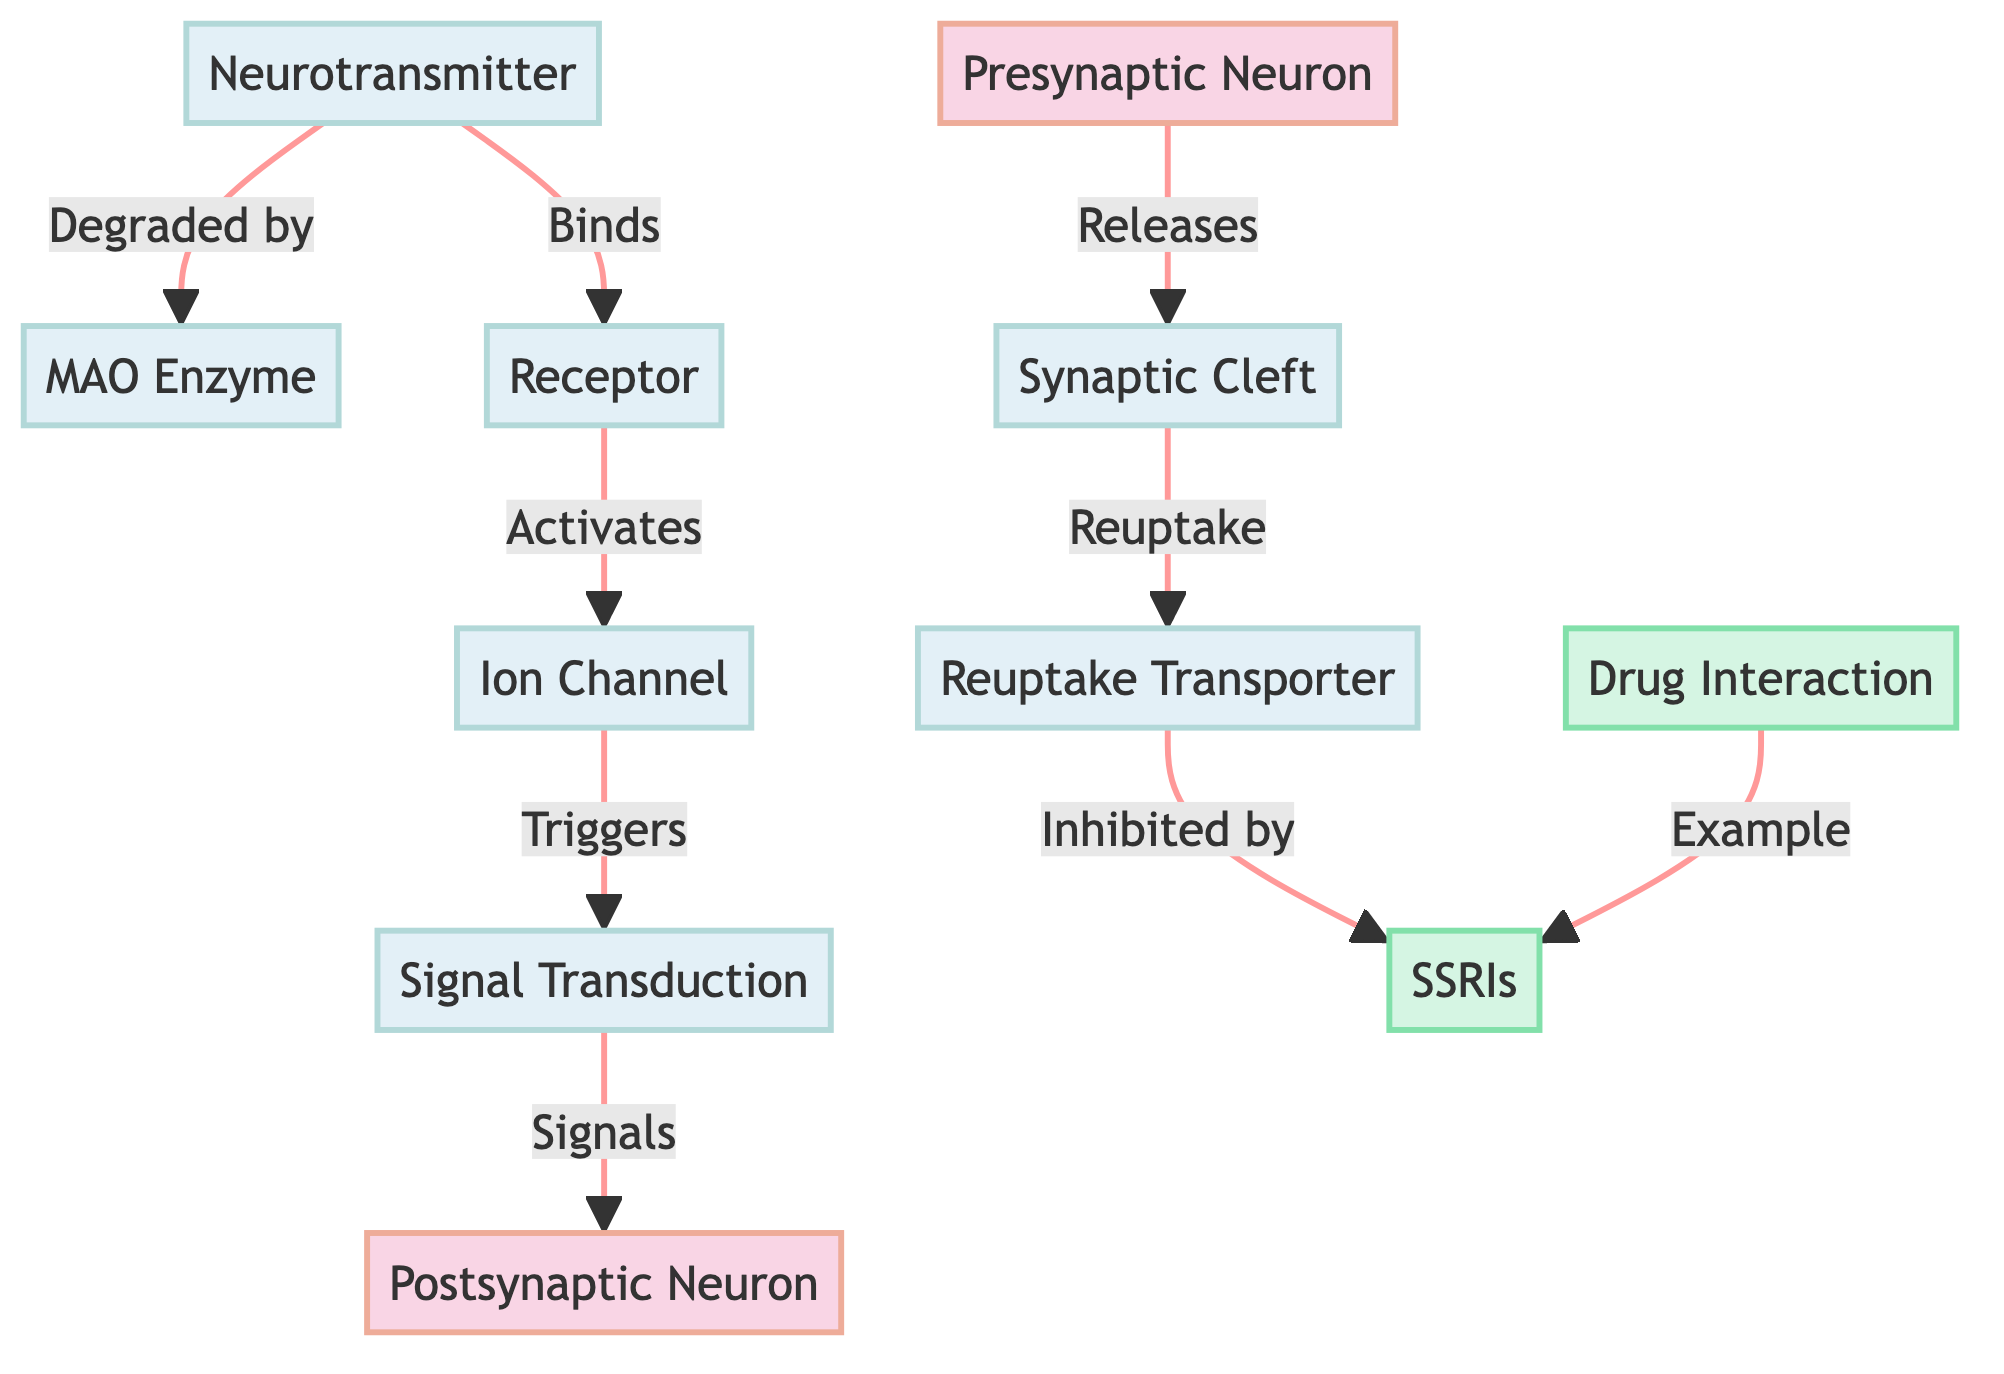What is the first node in the diagram? The first node in the diagram is labeled "Presynaptic Neuron," which is indicated as a critical starting point for the signaling pathway.
Answer: Presynaptic Neuron How many nodes are in the diagram? By counting each labeled component in the diagram, there are a total of 11 nodes, which include neurons, processes, and drug interactions.
Answer: 11 Which node is responsible for releasing neurotransmitters? The "Presynaptic Neuron" is identified as the source that releases neurotransmitters into the synaptic cleft.
Answer: Presynaptic Neuron What binds to the receptor in the process? The "Neurotransmitter" binds to the "Receptor," indicating the crucial interaction for signal propagation.
Answer: Neurotransmitter What is inhibited by SSRIs? The "Reuptake Transporter" is inhibited by SSRIs, preventing the reabsorption of neurotransmitters back into the presynaptic neuron.
Answer: Reuptake Transporter Which enzyme degrades neurotransmitters? The "MAO Enzyme" is responsible for degrading neurotransmitters in the synaptic cleft, which plays a significant role in their regulation.
Answer: MAO Enzyme Which node represents a drug interaction in the diagram? The node labeled "Drug Interaction" specifically represents the interactions related to drugs, highlighting their influence on the signaling pathway.
Answer: Drug Interaction What is the relationship between neurotransmitters and receptors? Neurotransmitters bind to receptors, which activates subsequent processes in the signal transduction pathway and facilitates communication between neurons.
Answer: Binds How does the signal get transferred to the postsynaptic neuron? The signal is transferred to the postsynaptic neuron through the activation of ion channels after neurotransmitters bind to receptors, resulting in signal transduction.
Answer: Ion Channels What example of a drug is mentioned in the diagram? The diagram mentions "SSRIs" as a specific example of a drug that interacts with the neuro-signaling pathways.
Answer: SSRIs 